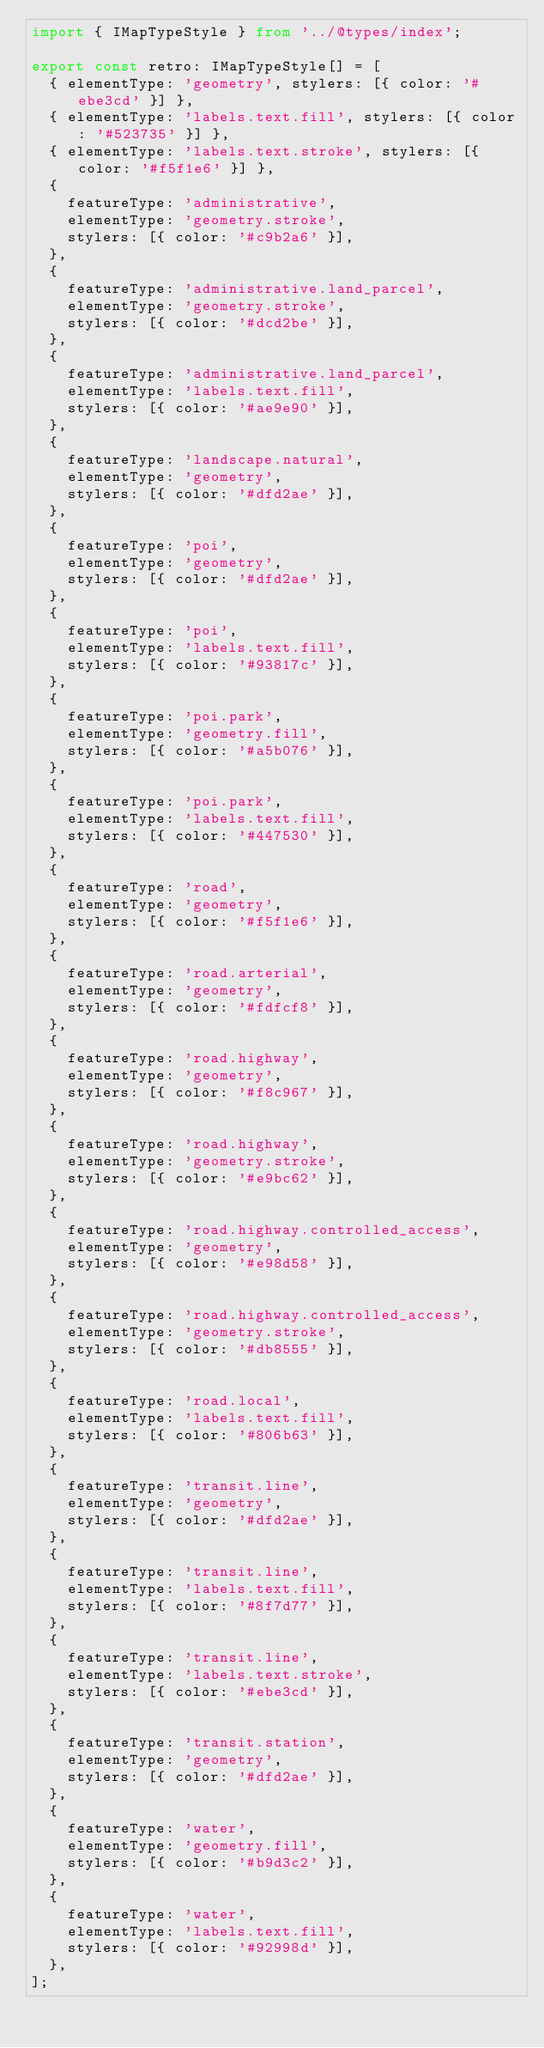<code> <loc_0><loc_0><loc_500><loc_500><_TypeScript_>import { IMapTypeStyle } from '../@types/index';

export const retro: IMapTypeStyle[] = [
  { elementType: 'geometry', stylers: [{ color: '#ebe3cd' }] },
  { elementType: 'labels.text.fill', stylers: [{ color: '#523735' }] },
  { elementType: 'labels.text.stroke', stylers: [{ color: '#f5f1e6' }] },
  {
    featureType: 'administrative',
    elementType: 'geometry.stroke',
    stylers: [{ color: '#c9b2a6' }],
  },
  {
    featureType: 'administrative.land_parcel',
    elementType: 'geometry.stroke',
    stylers: [{ color: '#dcd2be' }],
  },
  {
    featureType: 'administrative.land_parcel',
    elementType: 'labels.text.fill',
    stylers: [{ color: '#ae9e90' }],
  },
  {
    featureType: 'landscape.natural',
    elementType: 'geometry',
    stylers: [{ color: '#dfd2ae' }],
  },
  {
    featureType: 'poi',
    elementType: 'geometry',
    stylers: [{ color: '#dfd2ae' }],
  },
  {
    featureType: 'poi',
    elementType: 'labels.text.fill',
    stylers: [{ color: '#93817c' }],
  },
  {
    featureType: 'poi.park',
    elementType: 'geometry.fill',
    stylers: [{ color: '#a5b076' }],
  },
  {
    featureType: 'poi.park',
    elementType: 'labels.text.fill',
    stylers: [{ color: '#447530' }],
  },
  {
    featureType: 'road',
    elementType: 'geometry',
    stylers: [{ color: '#f5f1e6' }],
  },
  {
    featureType: 'road.arterial',
    elementType: 'geometry',
    stylers: [{ color: '#fdfcf8' }],
  },
  {
    featureType: 'road.highway',
    elementType: 'geometry',
    stylers: [{ color: '#f8c967' }],
  },
  {
    featureType: 'road.highway',
    elementType: 'geometry.stroke',
    stylers: [{ color: '#e9bc62' }],
  },
  {
    featureType: 'road.highway.controlled_access',
    elementType: 'geometry',
    stylers: [{ color: '#e98d58' }],
  },
  {
    featureType: 'road.highway.controlled_access',
    elementType: 'geometry.stroke',
    stylers: [{ color: '#db8555' }],
  },
  {
    featureType: 'road.local',
    elementType: 'labels.text.fill',
    stylers: [{ color: '#806b63' }],
  },
  {
    featureType: 'transit.line',
    elementType: 'geometry',
    stylers: [{ color: '#dfd2ae' }],
  },
  {
    featureType: 'transit.line',
    elementType: 'labels.text.fill',
    stylers: [{ color: '#8f7d77' }],
  },
  {
    featureType: 'transit.line',
    elementType: 'labels.text.stroke',
    stylers: [{ color: '#ebe3cd' }],
  },
  {
    featureType: 'transit.station',
    elementType: 'geometry',
    stylers: [{ color: '#dfd2ae' }],
  },
  {
    featureType: 'water',
    elementType: 'geometry.fill',
    stylers: [{ color: '#b9d3c2' }],
  },
  {
    featureType: 'water',
    elementType: 'labels.text.fill',
    stylers: [{ color: '#92998d' }],
  },
];
</code> 